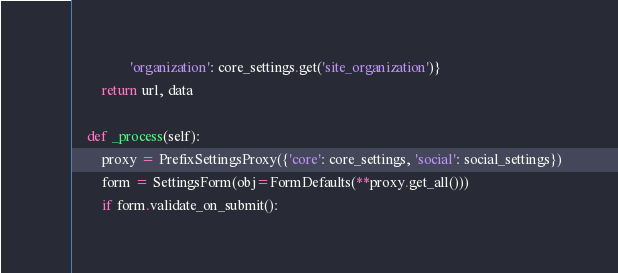<code> <loc_0><loc_0><loc_500><loc_500><_Python_>                'organization': core_settings.get('site_organization')}
        return url, data

    def _process(self):
        proxy = PrefixSettingsProxy({'core': core_settings, 'social': social_settings})
        form = SettingsForm(obj=FormDefaults(**proxy.get_all()))
        if form.validate_on_submit():</code> 